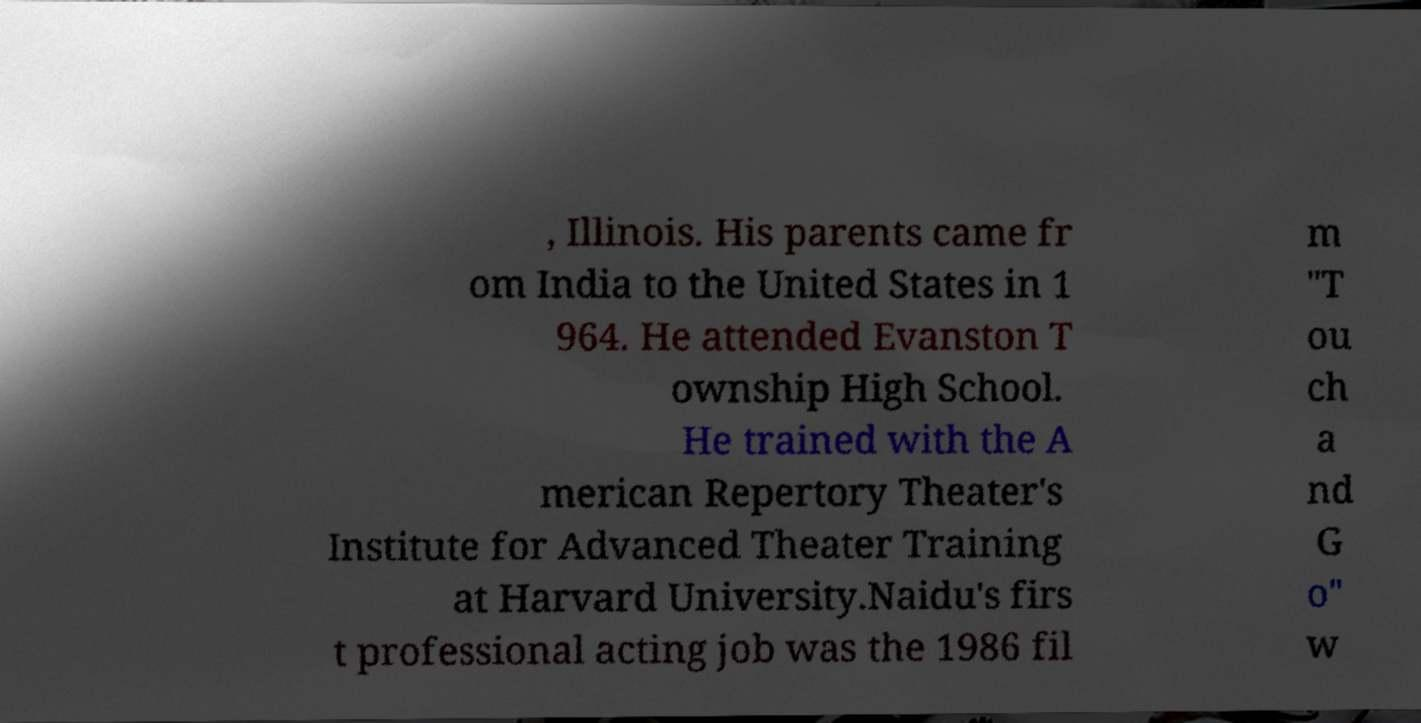Could you extract and type out the text from this image? , Illinois. His parents came fr om India to the United States in 1 964. He attended Evanston T ownship High School. He trained with the A merican Repertory Theater's Institute for Advanced Theater Training at Harvard University.Naidu's firs t professional acting job was the 1986 fil m "T ou ch a nd G o" w 